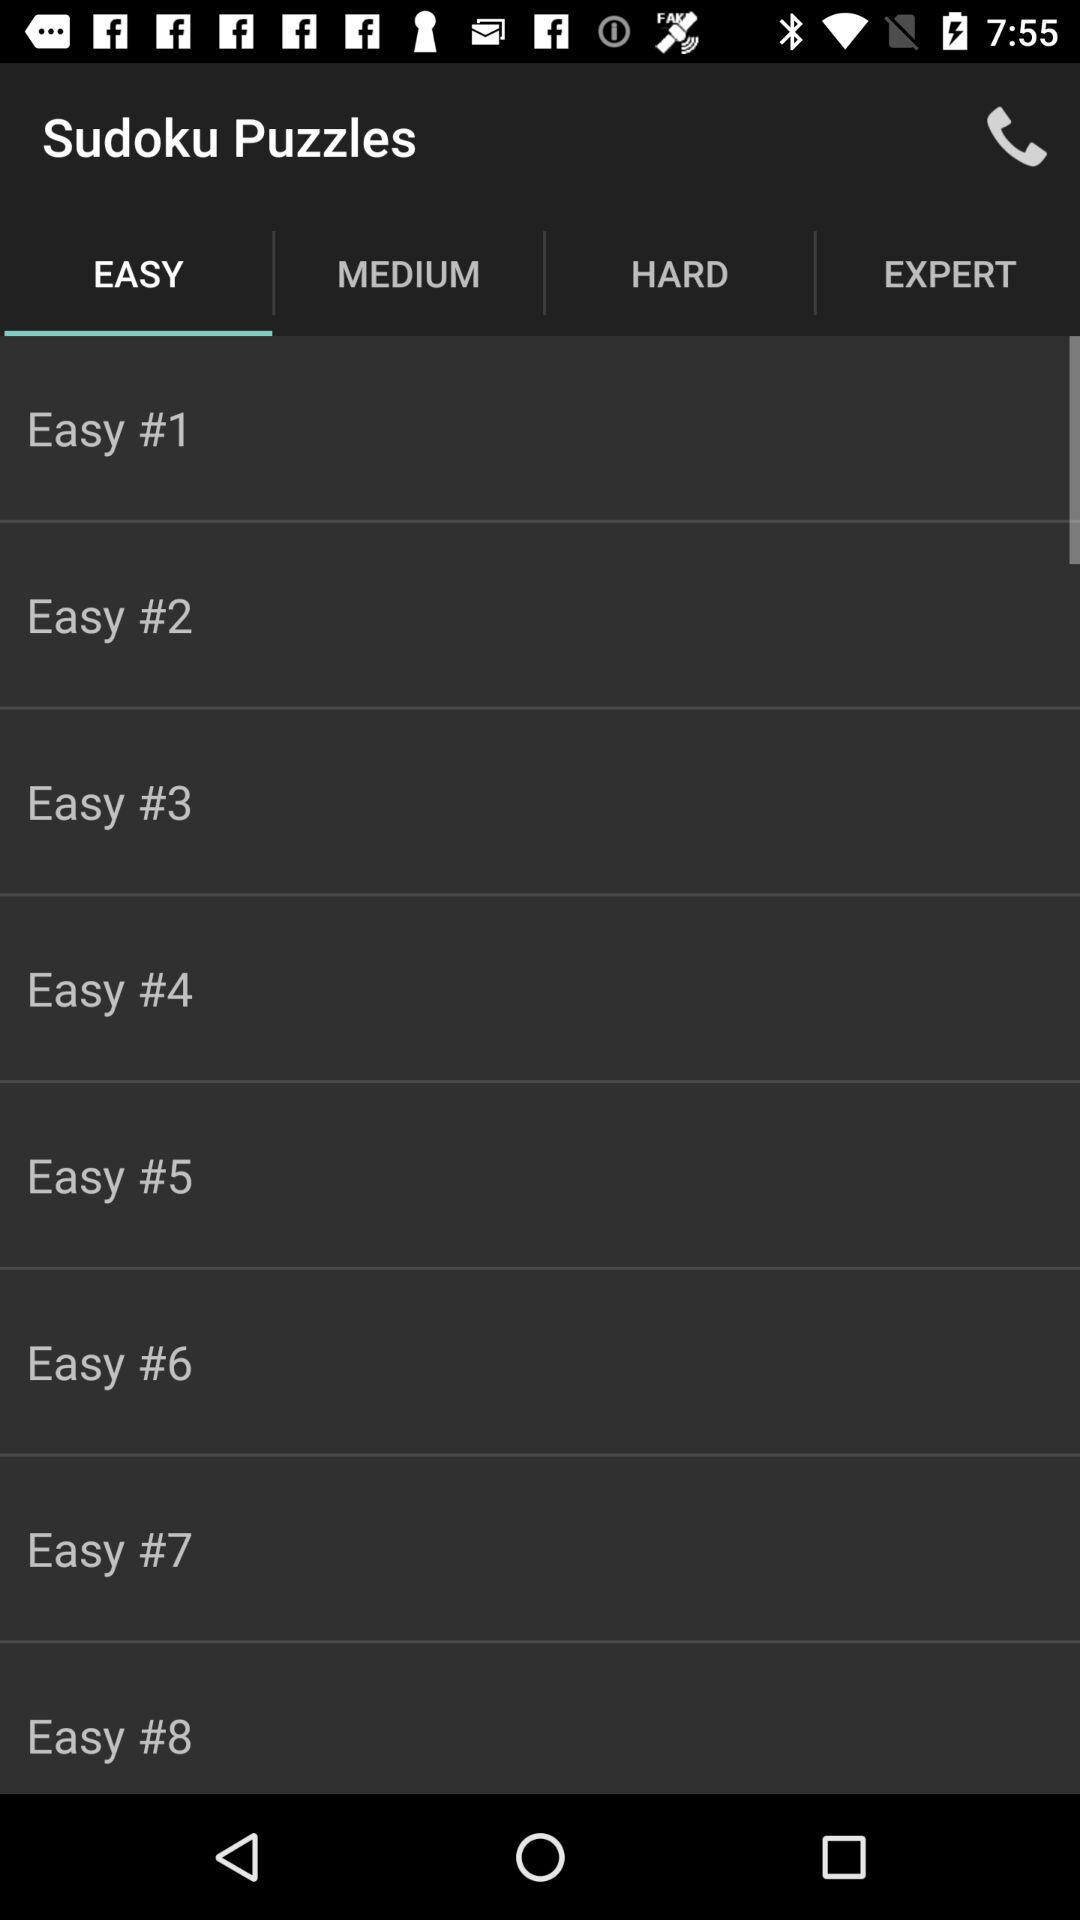What is the name of the application? The name of the application is "Sudoku Puzzles". 